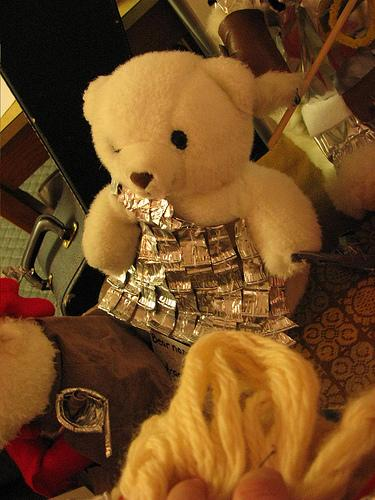Can you describe the texture of the wool strings in the image? The wool strings have a thick, cream-colored texture. What kind of material is covering the teddy bear's apron? The apron is covered by a reflective material. What facial features of the teddy bear are visible in the image? The teddy bear's dark black eyes, brown nose, and smile are visible in the image. What is beside the teddy bear, and what color is it? There is a briefcase beside the teddy bear, and it is black in color. List the colors mentioned in the image descriptions. (comma-separated) Cream, black, brown, silver Identify the main object in the image and describe its color and appearance. The main object is a white teddy bear that is fluffy and wearing a reflective silver dress. Describe the scene in the image including the objects and their positions. In the image, there is a white teddy bear in a reflective silver dress, with wool strings and ribbons around, and a black briefcase beside it. What material is the teddy bear's dress made of, and what color is it? The dress is made of a reflective, silvery material. Briefly describe the surface the teddy bear and other objects are placed on. The surface is a wooden table with a brown color. 